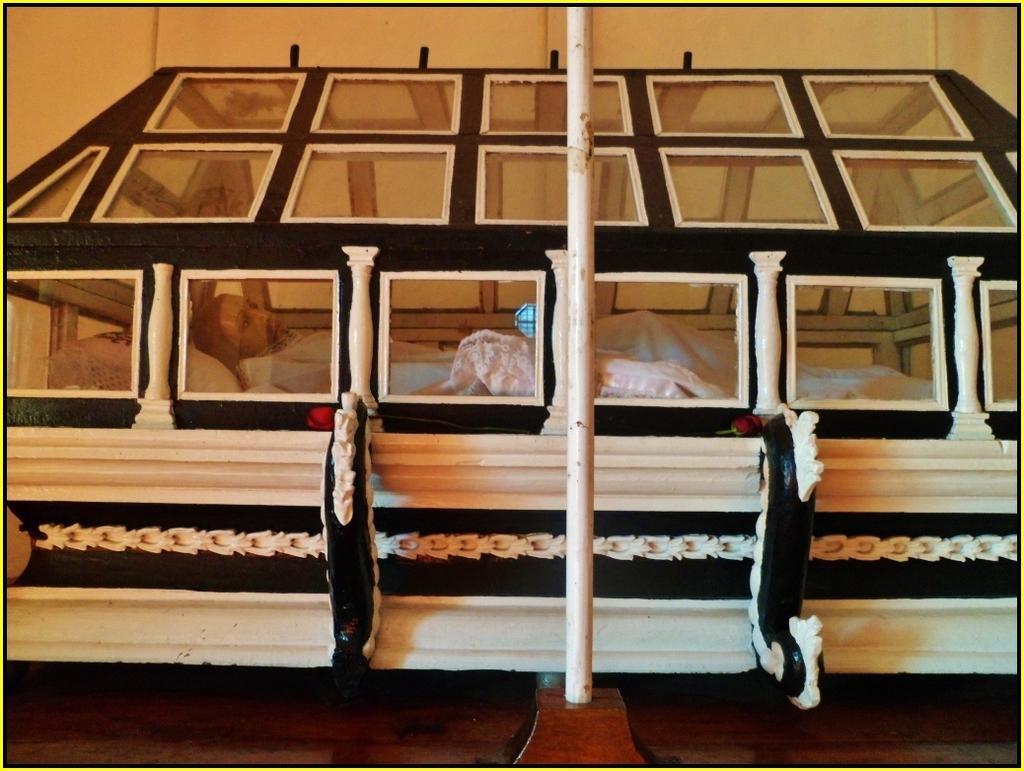In one or two sentences, can you explain what this image depicts? In this image I can see a pole, a white colour thing and in it I can see mannequin of a man wearing white dress. 